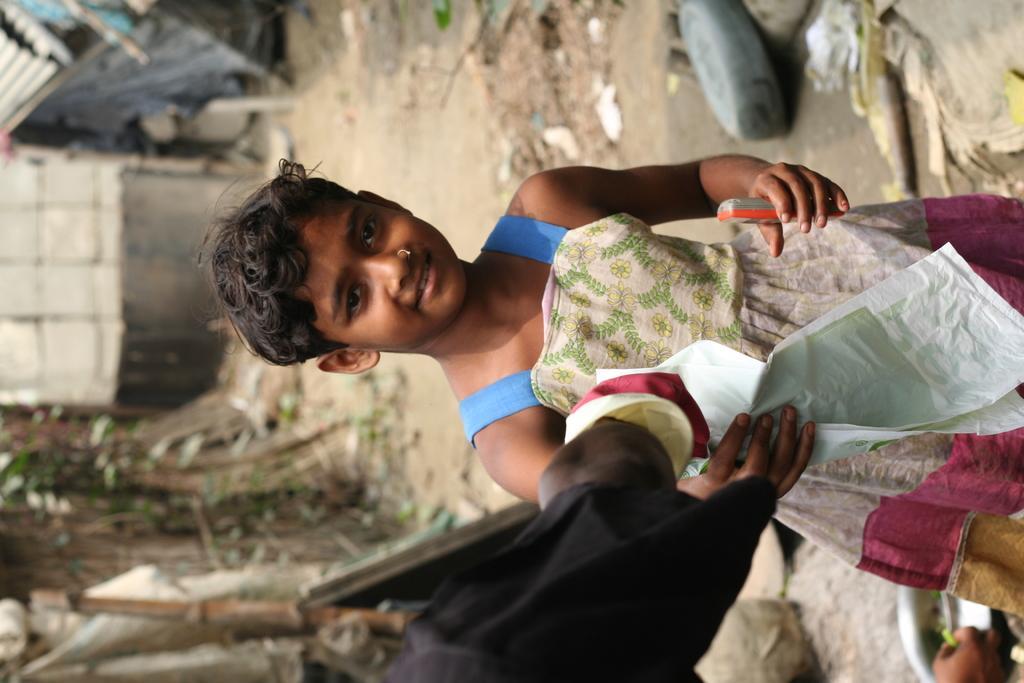Please provide a concise description of this image. In this image I can see the person is holding something. I can see few objects and blurred background. 